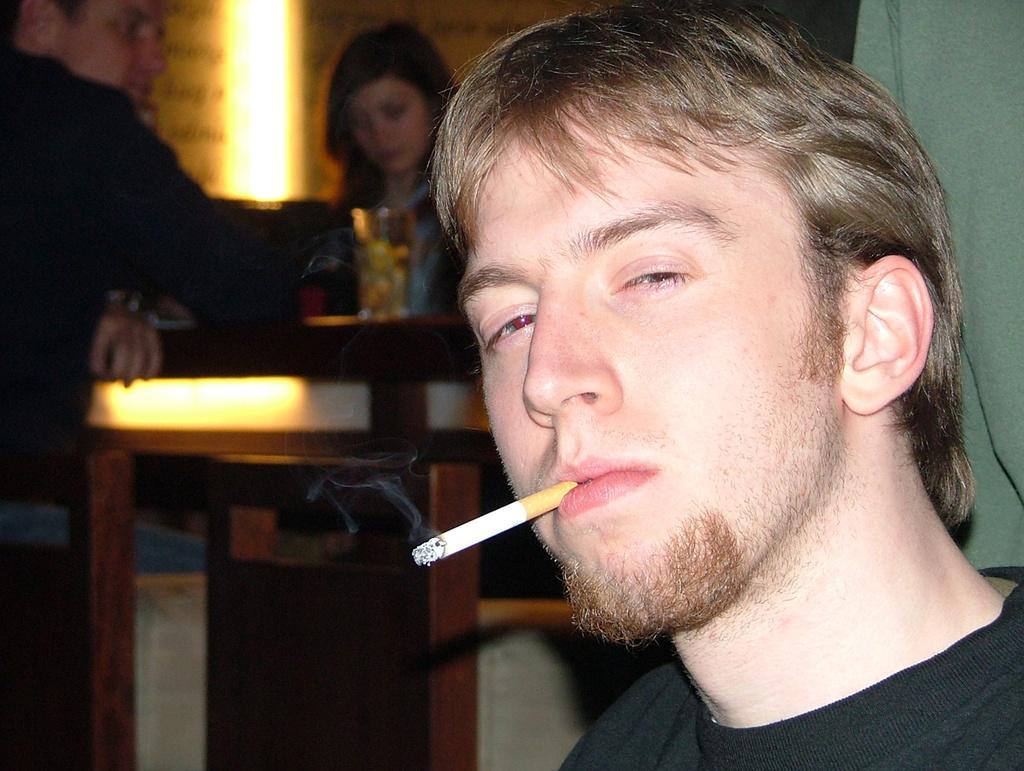How would you summarize this image in a sentence or two? In the image there is a person on right side in black t-shirt smoking cigarette, in the back there are few people sitting around table with wine glass on it. 